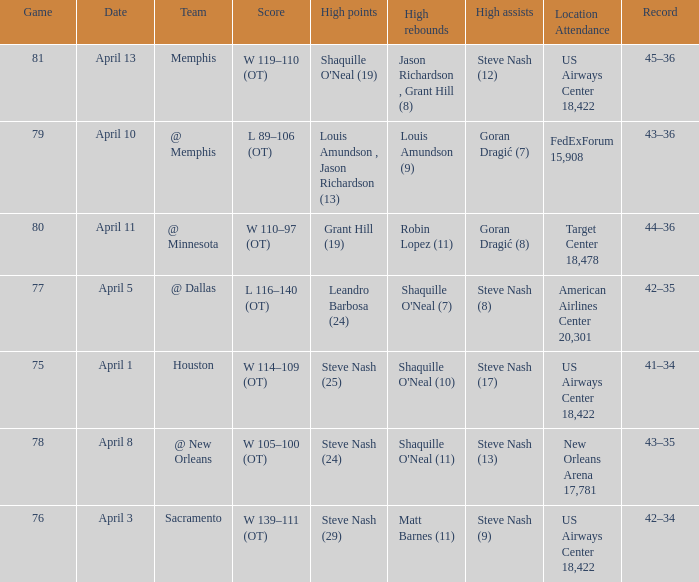Steve Nash (24) got high points for how many teams? 1.0. 